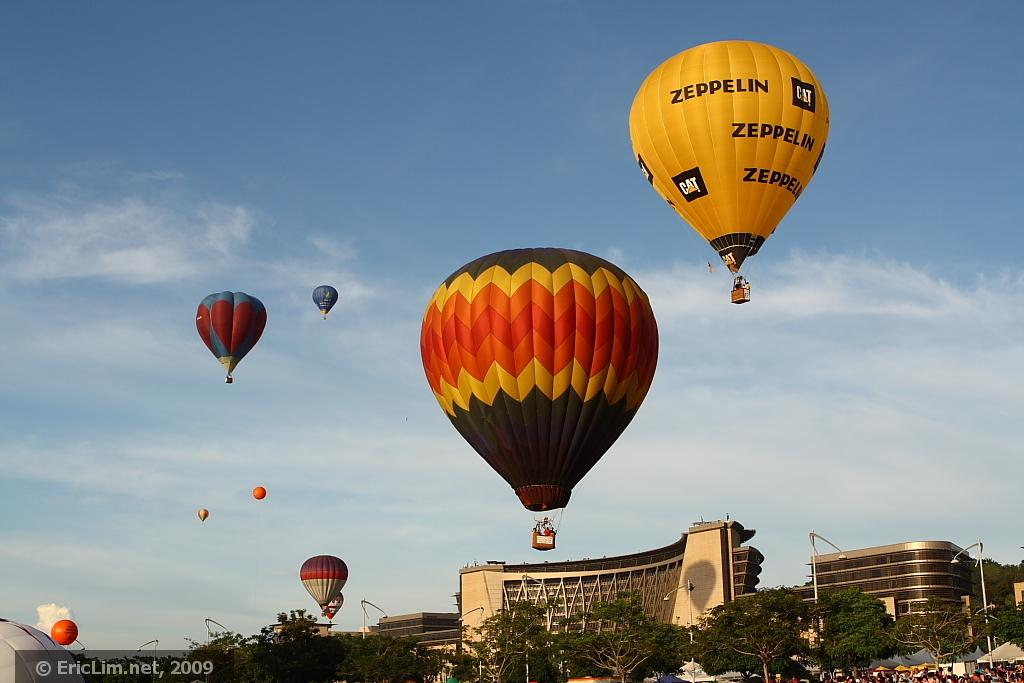<image>
Offer a succinct explanation of the picture presented. Many multi colored hot air balloons float about the city, one of them displaying ads for Zeppelin and CAT construction on them. 